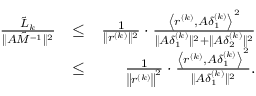Convert formula to latex. <formula><loc_0><loc_0><loc_500><loc_500>\begin{array} { r l r } { \frac { { { { \tilde { L } } _ { k } } } } { { \| { A \tilde { M } ^ { - 1 } } \| ^ { 2 } } } } & { \leq } & { \frac { 1 } { { \| r ^ { ( k ) } \| ^ { 2 } } } \cdot \frac { \left \langle { { r ^ { ( k ) } } , A \delta _ { 1 } ^ { ( k ) } } \right \rangle ^ { 2 } } { \| A \delta _ { 1 } ^ { ( k ) } \| ^ { 2 } + \| A \delta _ { 2 } ^ { ( k ) } \| ^ { 2 } } } \\ & { \leq } & { \frac { 1 } { { \left \| r ^ { ( k ) } \right \| ^ { 2 } } } \cdot \frac { \left \langle { { r ^ { ( k ) } } , A \delta _ { 1 } ^ { ( k ) } } \right \rangle ^ { 2 } } { \| A \delta _ { 1 } ^ { ( k ) } \| ^ { 2 } } . } \end{array}</formula> 